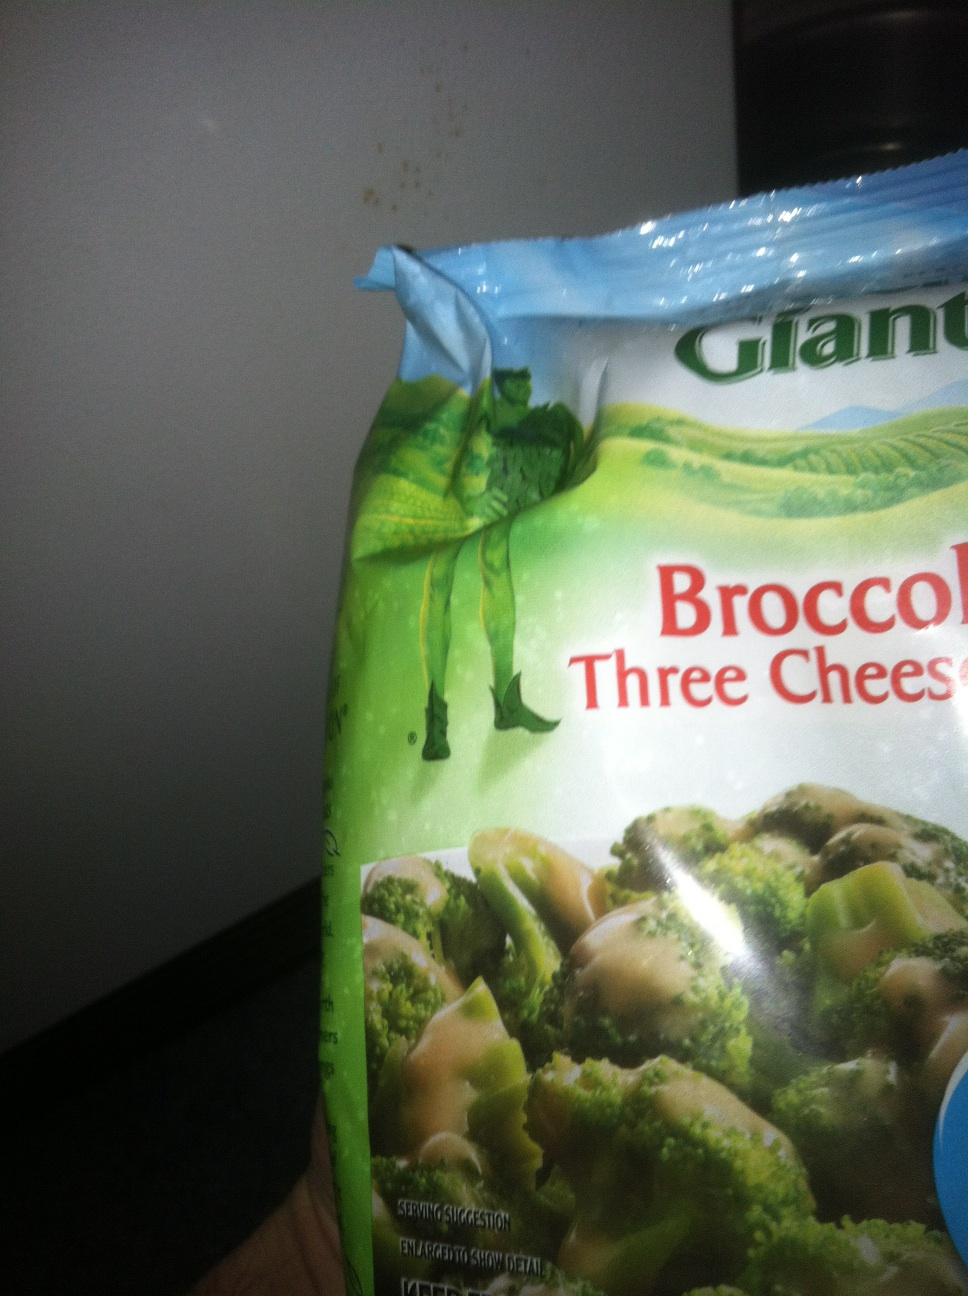Imagine this product in a fantasy world. What story could unfold? In the mystical land of Brocciopia, where vegetables are enchanted and giants roam, there exists a magical artifact known as the 'Cheese of Trifecta.' Legends say that this mystical cheese, guarded by the benevolent Green Giant, has the power to bring unity and prosperity to the land.

One day, a brave young gardener named Aria discovers an ancient map hidden in her grandmother's attic. The map reveals the path to the Green Giant's lair, where the Cheese of Trifecta is kept. Aria, armed with her trusty trowel and a spirit of adventure, sets out on a quest to find this legendary cheese.

Her journey is fraught with challenges: enchanted forests with broccoli trees that whisper secrets, rivers of molten cheddar guarded by fierce cheese sprites, and towering carrot peaks to navigate. Along the way, she meets a cast of quirky characters—talking vegetable creatures who share tales of the Green Giant’s wisdom and kindness.

After many trials, Aria finally reaches the Green Giant's emerald hills. There, she finds the Green Giant, who welcomes her with a feast prepared with the finest ingredients from Brocciopia. The centerpiece of the feast is a dish of broccoli covered in the divine Cheese of Trifecta.

As Aria tastes the legendary dish, she is filled with a sense of unity and peace. The Green Giant reveals that the true magic of the Cheese of Trifecta lies in its ability to bring people together, creating harmony in Brocciopia.

Aria returns to her village, sharing the magical broccoli and cheese sauce with her community. The land of Brocciopia flourishes, united by the magical meal that binds them together, all thanks to the enchanted 'Broccoli Three Cheese Sauce' and the wisdom of the Green Giant. 